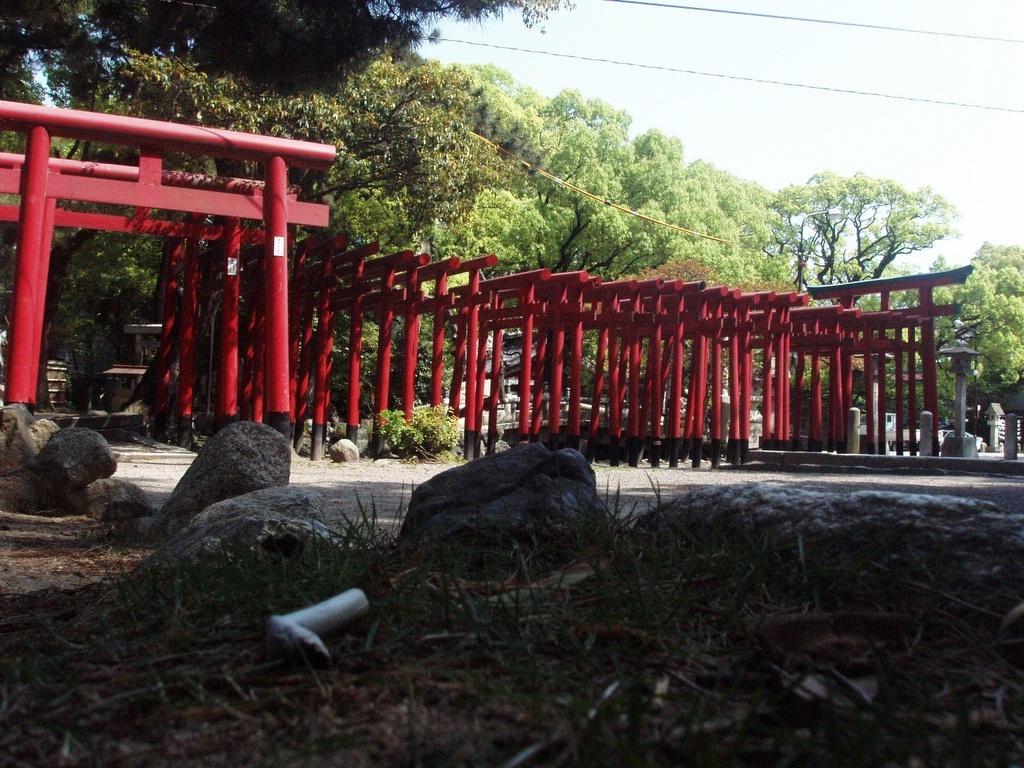In one or two sentences, can you explain what this image depicts? At the bottom of the image there is grass. There are stones. There are red color poles. In the background of the image there are trees. At the top of the image there is sky with wires. 